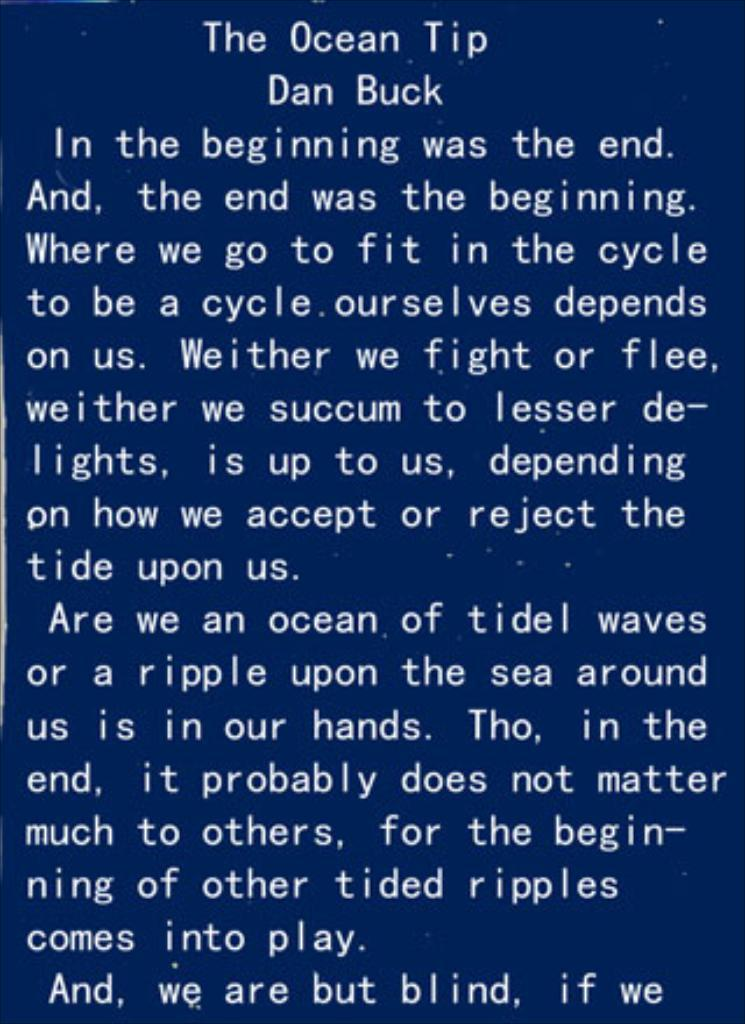<image>
Render a clear and concise summary of the photo. A message from The Ocean Tip by Dan Buck. 